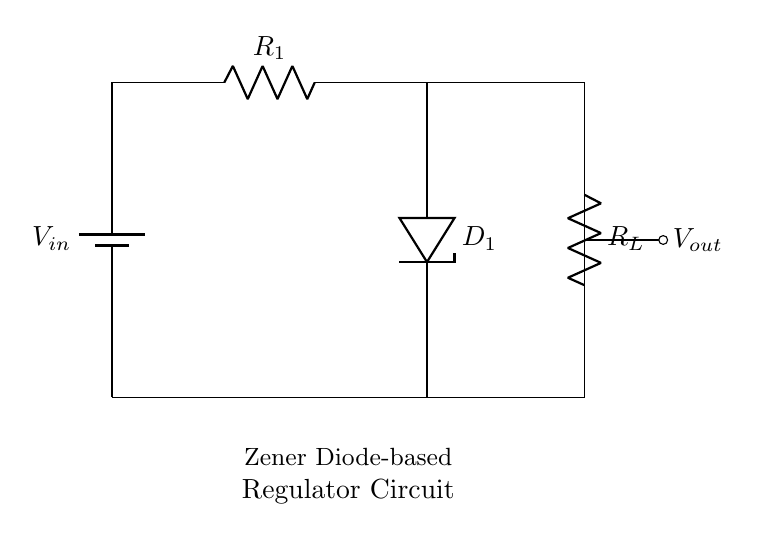What is the input voltage in the circuit? The input voltage is denoted as V_sub_in, which is the voltage provided by the battery at the top left.
Answer: V_sub_in What component limits the current in the circuit? The resistor labeled R1 limits the current flowing through the circuit by providing resistance, as shown in the diagram.
Answer: R1 What type of diode is used in this circuit? The circuit employs a Zener diode, indicated by the label D1 in the diagram, which is specifically designed to regulate voltage.
Answer: Zener diode How many resistors are in the circuit? There are two resistors shown in the diagram, R1 and R_L, which are clearly labeled in the circuit.
Answer: 2 What is the purpose of the Zener diode in this circuit? The Zener diode is used to maintain a stable output voltage by allowing reverse current to flow when the voltage exceeds a certain level, thus protecting the load.
Answer: Voltage regulation Which component is responsible for the load in this circuit? The resistor labeled R_L acts as the load in this circuit, where the regulated voltage is utilized after passing through the Zener diode.
Answer: R_L 